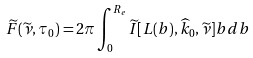Convert formula to latex. <formula><loc_0><loc_0><loc_500><loc_500>\widetilde { F } ( \widetilde { \nu } , \tau _ { 0 } ) = 2 \pi \int _ { 0 } ^ { R _ { e } } \widetilde { I } [ L ( b ) , \widehat { k } _ { 0 } , \widetilde { \nu } ] b d b</formula> 